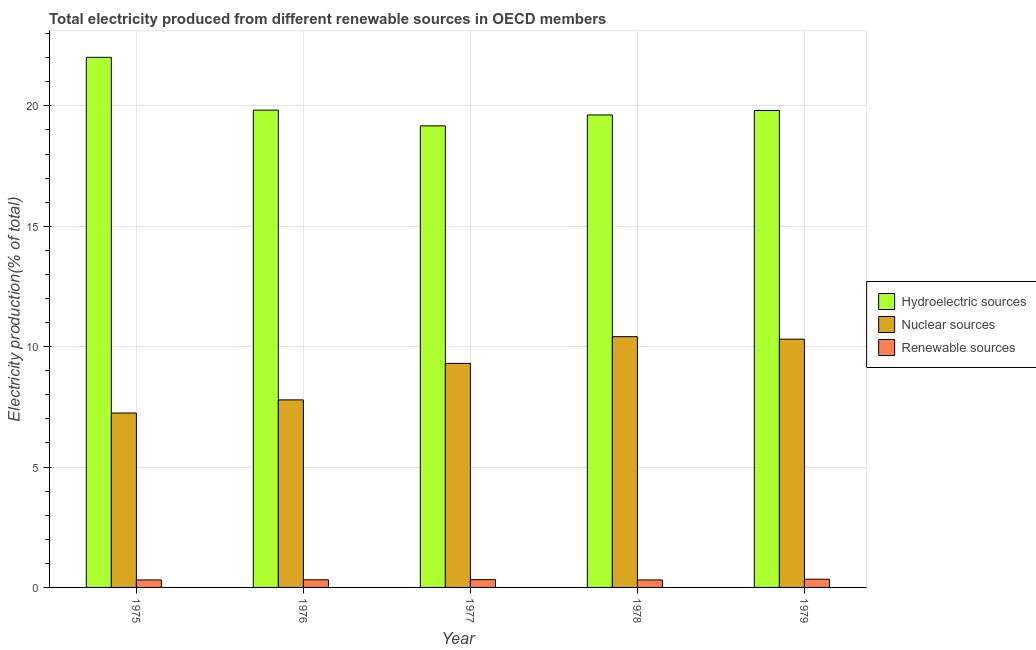Are the number of bars on each tick of the X-axis equal?
Offer a very short reply. Yes. How many bars are there on the 5th tick from the right?
Provide a succinct answer. 3. What is the label of the 4th group of bars from the left?
Give a very brief answer. 1978. In how many cases, is the number of bars for a given year not equal to the number of legend labels?
Provide a short and direct response. 0. What is the percentage of electricity produced by renewable sources in 1977?
Your answer should be very brief. 0.32. Across all years, what is the maximum percentage of electricity produced by renewable sources?
Your response must be concise. 0.34. Across all years, what is the minimum percentage of electricity produced by hydroelectric sources?
Your response must be concise. 19.17. In which year was the percentage of electricity produced by renewable sources maximum?
Ensure brevity in your answer.  1979. In which year was the percentage of electricity produced by renewable sources minimum?
Your answer should be very brief. 1978. What is the total percentage of electricity produced by nuclear sources in the graph?
Your answer should be very brief. 45.06. What is the difference between the percentage of electricity produced by renewable sources in 1976 and that in 1979?
Give a very brief answer. -0.02. What is the difference between the percentage of electricity produced by nuclear sources in 1978 and the percentage of electricity produced by renewable sources in 1977?
Offer a terse response. 1.11. What is the average percentage of electricity produced by hydroelectric sources per year?
Offer a very short reply. 20.09. What is the ratio of the percentage of electricity produced by hydroelectric sources in 1976 to that in 1979?
Make the answer very short. 1. What is the difference between the highest and the second highest percentage of electricity produced by renewable sources?
Your response must be concise. 0.02. What is the difference between the highest and the lowest percentage of electricity produced by hydroelectric sources?
Offer a terse response. 2.85. Is the sum of the percentage of electricity produced by hydroelectric sources in 1975 and 1976 greater than the maximum percentage of electricity produced by nuclear sources across all years?
Ensure brevity in your answer.  Yes. What does the 1st bar from the left in 1979 represents?
Ensure brevity in your answer.  Hydroelectric sources. What does the 1st bar from the right in 1976 represents?
Offer a terse response. Renewable sources. Is it the case that in every year, the sum of the percentage of electricity produced by hydroelectric sources and percentage of electricity produced by nuclear sources is greater than the percentage of electricity produced by renewable sources?
Give a very brief answer. Yes. How many bars are there?
Give a very brief answer. 15. How many years are there in the graph?
Your answer should be very brief. 5. What is the difference between two consecutive major ticks on the Y-axis?
Ensure brevity in your answer.  5. Does the graph contain grids?
Ensure brevity in your answer.  Yes. How are the legend labels stacked?
Provide a succinct answer. Vertical. What is the title of the graph?
Offer a very short reply. Total electricity produced from different renewable sources in OECD members. Does "Private sector" appear as one of the legend labels in the graph?
Your response must be concise. No. What is the label or title of the X-axis?
Your answer should be compact. Year. What is the label or title of the Y-axis?
Provide a succinct answer. Electricity production(% of total). What is the Electricity production(% of total) of Hydroelectric sources in 1975?
Give a very brief answer. 22.02. What is the Electricity production(% of total) of Nuclear sources in 1975?
Your response must be concise. 7.24. What is the Electricity production(% of total) of Renewable sources in 1975?
Offer a very short reply. 0.31. What is the Electricity production(% of total) of Hydroelectric sources in 1976?
Keep it short and to the point. 19.82. What is the Electricity production(% of total) in Nuclear sources in 1976?
Your answer should be very brief. 7.79. What is the Electricity production(% of total) of Renewable sources in 1976?
Your response must be concise. 0.32. What is the Electricity production(% of total) in Hydroelectric sources in 1977?
Ensure brevity in your answer.  19.17. What is the Electricity production(% of total) of Nuclear sources in 1977?
Keep it short and to the point. 9.31. What is the Electricity production(% of total) in Renewable sources in 1977?
Your answer should be compact. 0.32. What is the Electricity production(% of total) in Hydroelectric sources in 1978?
Your response must be concise. 19.62. What is the Electricity production(% of total) in Nuclear sources in 1978?
Provide a succinct answer. 10.42. What is the Electricity production(% of total) of Renewable sources in 1978?
Your answer should be very brief. 0.31. What is the Electricity production(% of total) of Hydroelectric sources in 1979?
Your answer should be very brief. 19.81. What is the Electricity production(% of total) of Nuclear sources in 1979?
Your answer should be very brief. 10.31. What is the Electricity production(% of total) of Renewable sources in 1979?
Provide a succinct answer. 0.34. Across all years, what is the maximum Electricity production(% of total) in Hydroelectric sources?
Give a very brief answer. 22.02. Across all years, what is the maximum Electricity production(% of total) in Nuclear sources?
Give a very brief answer. 10.42. Across all years, what is the maximum Electricity production(% of total) in Renewable sources?
Your answer should be very brief. 0.34. Across all years, what is the minimum Electricity production(% of total) in Hydroelectric sources?
Give a very brief answer. 19.17. Across all years, what is the minimum Electricity production(% of total) in Nuclear sources?
Your response must be concise. 7.24. Across all years, what is the minimum Electricity production(% of total) of Renewable sources?
Keep it short and to the point. 0.31. What is the total Electricity production(% of total) of Hydroelectric sources in the graph?
Keep it short and to the point. 100.44. What is the total Electricity production(% of total) of Nuclear sources in the graph?
Your answer should be compact. 45.06. What is the total Electricity production(% of total) in Renewable sources in the graph?
Provide a succinct answer. 1.6. What is the difference between the Electricity production(% of total) in Hydroelectric sources in 1975 and that in 1976?
Keep it short and to the point. 2.19. What is the difference between the Electricity production(% of total) in Nuclear sources in 1975 and that in 1976?
Make the answer very short. -0.55. What is the difference between the Electricity production(% of total) in Renewable sources in 1975 and that in 1976?
Give a very brief answer. -0.01. What is the difference between the Electricity production(% of total) in Hydroelectric sources in 1975 and that in 1977?
Provide a short and direct response. 2.85. What is the difference between the Electricity production(% of total) in Nuclear sources in 1975 and that in 1977?
Provide a short and direct response. -2.06. What is the difference between the Electricity production(% of total) of Renewable sources in 1975 and that in 1977?
Provide a succinct answer. -0.01. What is the difference between the Electricity production(% of total) in Hydroelectric sources in 1975 and that in 1978?
Give a very brief answer. 2.39. What is the difference between the Electricity production(% of total) of Nuclear sources in 1975 and that in 1978?
Keep it short and to the point. -3.17. What is the difference between the Electricity production(% of total) in Hydroelectric sources in 1975 and that in 1979?
Offer a terse response. 2.21. What is the difference between the Electricity production(% of total) in Nuclear sources in 1975 and that in 1979?
Your answer should be compact. -3.07. What is the difference between the Electricity production(% of total) of Renewable sources in 1975 and that in 1979?
Provide a succinct answer. -0.03. What is the difference between the Electricity production(% of total) in Hydroelectric sources in 1976 and that in 1977?
Provide a succinct answer. 0.65. What is the difference between the Electricity production(% of total) of Nuclear sources in 1976 and that in 1977?
Keep it short and to the point. -1.52. What is the difference between the Electricity production(% of total) in Renewable sources in 1976 and that in 1977?
Your response must be concise. -0.01. What is the difference between the Electricity production(% of total) of Hydroelectric sources in 1976 and that in 1978?
Your response must be concise. 0.2. What is the difference between the Electricity production(% of total) of Nuclear sources in 1976 and that in 1978?
Your answer should be very brief. -2.63. What is the difference between the Electricity production(% of total) in Renewable sources in 1976 and that in 1978?
Make the answer very short. 0.01. What is the difference between the Electricity production(% of total) of Hydroelectric sources in 1976 and that in 1979?
Ensure brevity in your answer.  0.02. What is the difference between the Electricity production(% of total) in Nuclear sources in 1976 and that in 1979?
Provide a succinct answer. -2.52. What is the difference between the Electricity production(% of total) in Renewable sources in 1976 and that in 1979?
Your answer should be very brief. -0.02. What is the difference between the Electricity production(% of total) of Hydroelectric sources in 1977 and that in 1978?
Ensure brevity in your answer.  -0.45. What is the difference between the Electricity production(% of total) in Nuclear sources in 1977 and that in 1978?
Make the answer very short. -1.11. What is the difference between the Electricity production(% of total) in Renewable sources in 1977 and that in 1978?
Provide a short and direct response. 0.01. What is the difference between the Electricity production(% of total) of Hydroelectric sources in 1977 and that in 1979?
Make the answer very short. -0.64. What is the difference between the Electricity production(% of total) in Nuclear sources in 1977 and that in 1979?
Your response must be concise. -1.01. What is the difference between the Electricity production(% of total) of Renewable sources in 1977 and that in 1979?
Offer a terse response. -0.02. What is the difference between the Electricity production(% of total) of Hydroelectric sources in 1978 and that in 1979?
Ensure brevity in your answer.  -0.18. What is the difference between the Electricity production(% of total) in Nuclear sources in 1978 and that in 1979?
Your answer should be compact. 0.1. What is the difference between the Electricity production(% of total) of Renewable sources in 1978 and that in 1979?
Give a very brief answer. -0.03. What is the difference between the Electricity production(% of total) of Hydroelectric sources in 1975 and the Electricity production(% of total) of Nuclear sources in 1976?
Provide a succinct answer. 14.23. What is the difference between the Electricity production(% of total) of Hydroelectric sources in 1975 and the Electricity production(% of total) of Renewable sources in 1976?
Your answer should be compact. 21.7. What is the difference between the Electricity production(% of total) of Nuclear sources in 1975 and the Electricity production(% of total) of Renewable sources in 1976?
Your answer should be very brief. 6.93. What is the difference between the Electricity production(% of total) of Hydroelectric sources in 1975 and the Electricity production(% of total) of Nuclear sources in 1977?
Your answer should be compact. 12.71. What is the difference between the Electricity production(% of total) of Hydroelectric sources in 1975 and the Electricity production(% of total) of Renewable sources in 1977?
Your answer should be very brief. 21.69. What is the difference between the Electricity production(% of total) of Nuclear sources in 1975 and the Electricity production(% of total) of Renewable sources in 1977?
Ensure brevity in your answer.  6.92. What is the difference between the Electricity production(% of total) of Hydroelectric sources in 1975 and the Electricity production(% of total) of Nuclear sources in 1978?
Ensure brevity in your answer.  11.6. What is the difference between the Electricity production(% of total) in Hydroelectric sources in 1975 and the Electricity production(% of total) in Renewable sources in 1978?
Provide a succinct answer. 21.71. What is the difference between the Electricity production(% of total) in Nuclear sources in 1975 and the Electricity production(% of total) in Renewable sources in 1978?
Keep it short and to the point. 6.93. What is the difference between the Electricity production(% of total) in Hydroelectric sources in 1975 and the Electricity production(% of total) in Nuclear sources in 1979?
Provide a succinct answer. 11.71. What is the difference between the Electricity production(% of total) in Hydroelectric sources in 1975 and the Electricity production(% of total) in Renewable sources in 1979?
Your answer should be very brief. 21.68. What is the difference between the Electricity production(% of total) in Nuclear sources in 1975 and the Electricity production(% of total) in Renewable sources in 1979?
Give a very brief answer. 6.9. What is the difference between the Electricity production(% of total) in Hydroelectric sources in 1976 and the Electricity production(% of total) in Nuclear sources in 1977?
Your answer should be compact. 10.52. What is the difference between the Electricity production(% of total) in Hydroelectric sources in 1976 and the Electricity production(% of total) in Renewable sources in 1977?
Offer a terse response. 19.5. What is the difference between the Electricity production(% of total) in Nuclear sources in 1976 and the Electricity production(% of total) in Renewable sources in 1977?
Your answer should be compact. 7.47. What is the difference between the Electricity production(% of total) of Hydroelectric sources in 1976 and the Electricity production(% of total) of Nuclear sources in 1978?
Provide a succinct answer. 9.41. What is the difference between the Electricity production(% of total) of Hydroelectric sources in 1976 and the Electricity production(% of total) of Renewable sources in 1978?
Make the answer very short. 19.51. What is the difference between the Electricity production(% of total) in Nuclear sources in 1976 and the Electricity production(% of total) in Renewable sources in 1978?
Keep it short and to the point. 7.48. What is the difference between the Electricity production(% of total) in Hydroelectric sources in 1976 and the Electricity production(% of total) in Nuclear sources in 1979?
Provide a short and direct response. 9.51. What is the difference between the Electricity production(% of total) of Hydroelectric sources in 1976 and the Electricity production(% of total) of Renewable sources in 1979?
Provide a short and direct response. 19.48. What is the difference between the Electricity production(% of total) in Nuclear sources in 1976 and the Electricity production(% of total) in Renewable sources in 1979?
Make the answer very short. 7.45. What is the difference between the Electricity production(% of total) of Hydroelectric sources in 1977 and the Electricity production(% of total) of Nuclear sources in 1978?
Provide a short and direct response. 8.75. What is the difference between the Electricity production(% of total) of Hydroelectric sources in 1977 and the Electricity production(% of total) of Renewable sources in 1978?
Offer a terse response. 18.86. What is the difference between the Electricity production(% of total) of Nuclear sources in 1977 and the Electricity production(% of total) of Renewable sources in 1978?
Your answer should be compact. 8.99. What is the difference between the Electricity production(% of total) in Hydroelectric sources in 1977 and the Electricity production(% of total) in Nuclear sources in 1979?
Ensure brevity in your answer.  8.86. What is the difference between the Electricity production(% of total) in Hydroelectric sources in 1977 and the Electricity production(% of total) in Renewable sources in 1979?
Make the answer very short. 18.83. What is the difference between the Electricity production(% of total) in Nuclear sources in 1977 and the Electricity production(% of total) in Renewable sources in 1979?
Provide a short and direct response. 8.96. What is the difference between the Electricity production(% of total) of Hydroelectric sources in 1978 and the Electricity production(% of total) of Nuclear sources in 1979?
Your answer should be very brief. 9.31. What is the difference between the Electricity production(% of total) in Hydroelectric sources in 1978 and the Electricity production(% of total) in Renewable sources in 1979?
Your answer should be very brief. 19.28. What is the difference between the Electricity production(% of total) of Nuclear sources in 1978 and the Electricity production(% of total) of Renewable sources in 1979?
Your answer should be compact. 10.07. What is the average Electricity production(% of total) of Hydroelectric sources per year?
Your answer should be compact. 20.09. What is the average Electricity production(% of total) of Nuclear sources per year?
Provide a short and direct response. 9.01. What is the average Electricity production(% of total) of Renewable sources per year?
Make the answer very short. 0.32. In the year 1975, what is the difference between the Electricity production(% of total) in Hydroelectric sources and Electricity production(% of total) in Nuclear sources?
Offer a very short reply. 14.77. In the year 1975, what is the difference between the Electricity production(% of total) of Hydroelectric sources and Electricity production(% of total) of Renewable sources?
Your response must be concise. 21.7. In the year 1975, what is the difference between the Electricity production(% of total) of Nuclear sources and Electricity production(% of total) of Renewable sources?
Your answer should be compact. 6.93. In the year 1976, what is the difference between the Electricity production(% of total) of Hydroelectric sources and Electricity production(% of total) of Nuclear sources?
Provide a short and direct response. 12.03. In the year 1976, what is the difference between the Electricity production(% of total) of Hydroelectric sources and Electricity production(% of total) of Renewable sources?
Provide a succinct answer. 19.51. In the year 1976, what is the difference between the Electricity production(% of total) of Nuclear sources and Electricity production(% of total) of Renewable sources?
Provide a succinct answer. 7.47. In the year 1977, what is the difference between the Electricity production(% of total) of Hydroelectric sources and Electricity production(% of total) of Nuclear sources?
Ensure brevity in your answer.  9.86. In the year 1977, what is the difference between the Electricity production(% of total) in Hydroelectric sources and Electricity production(% of total) in Renewable sources?
Keep it short and to the point. 18.85. In the year 1977, what is the difference between the Electricity production(% of total) in Nuclear sources and Electricity production(% of total) in Renewable sources?
Make the answer very short. 8.98. In the year 1978, what is the difference between the Electricity production(% of total) of Hydroelectric sources and Electricity production(% of total) of Nuclear sources?
Offer a terse response. 9.21. In the year 1978, what is the difference between the Electricity production(% of total) of Hydroelectric sources and Electricity production(% of total) of Renewable sources?
Offer a very short reply. 19.31. In the year 1978, what is the difference between the Electricity production(% of total) of Nuclear sources and Electricity production(% of total) of Renewable sources?
Your response must be concise. 10.1. In the year 1979, what is the difference between the Electricity production(% of total) of Hydroelectric sources and Electricity production(% of total) of Nuclear sources?
Make the answer very short. 9.5. In the year 1979, what is the difference between the Electricity production(% of total) of Hydroelectric sources and Electricity production(% of total) of Renewable sources?
Ensure brevity in your answer.  19.47. In the year 1979, what is the difference between the Electricity production(% of total) of Nuclear sources and Electricity production(% of total) of Renewable sources?
Provide a succinct answer. 9.97. What is the ratio of the Electricity production(% of total) of Hydroelectric sources in 1975 to that in 1976?
Your answer should be compact. 1.11. What is the ratio of the Electricity production(% of total) of Nuclear sources in 1975 to that in 1976?
Ensure brevity in your answer.  0.93. What is the ratio of the Electricity production(% of total) in Renewable sources in 1975 to that in 1976?
Ensure brevity in your answer.  0.98. What is the ratio of the Electricity production(% of total) of Hydroelectric sources in 1975 to that in 1977?
Keep it short and to the point. 1.15. What is the ratio of the Electricity production(% of total) in Nuclear sources in 1975 to that in 1977?
Provide a short and direct response. 0.78. What is the ratio of the Electricity production(% of total) of Hydroelectric sources in 1975 to that in 1978?
Ensure brevity in your answer.  1.12. What is the ratio of the Electricity production(% of total) in Nuclear sources in 1975 to that in 1978?
Keep it short and to the point. 0.7. What is the ratio of the Electricity production(% of total) of Hydroelectric sources in 1975 to that in 1979?
Offer a terse response. 1.11. What is the ratio of the Electricity production(% of total) of Nuclear sources in 1975 to that in 1979?
Provide a succinct answer. 0.7. What is the ratio of the Electricity production(% of total) of Hydroelectric sources in 1976 to that in 1977?
Your response must be concise. 1.03. What is the ratio of the Electricity production(% of total) in Nuclear sources in 1976 to that in 1977?
Provide a succinct answer. 0.84. What is the ratio of the Electricity production(% of total) of Renewable sources in 1976 to that in 1977?
Provide a succinct answer. 0.98. What is the ratio of the Electricity production(% of total) in Hydroelectric sources in 1976 to that in 1978?
Make the answer very short. 1.01. What is the ratio of the Electricity production(% of total) of Nuclear sources in 1976 to that in 1978?
Keep it short and to the point. 0.75. What is the ratio of the Electricity production(% of total) of Renewable sources in 1976 to that in 1978?
Keep it short and to the point. 1.02. What is the ratio of the Electricity production(% of total) in Hydroelectric sources in 1976 to that in 1979?
Offer a very short reply. 1. What is the ratio of the Electricity production(% of total) in Nuclear sources in 1976 to that in 1979?
Give a very brief answer. 0.76. What is the ratio of the Electricity production(% of total) in Renewable sources in 1976 to that in 1979?
Offer a terse response. 0.93. What is the ratio of the Electricity production(% of total) of Hydroelectric sources in 1977 to that in 1978?
Ensure brevity in your answer.  0.98. What is the ratio of the Electricity production(% of total) in Nuclear sources in 1977 to that in 1978?
Ensure brevity in your answer.  0.89. What is the ratio of the Electricity production(% of total) of Renewable sources in 1977 to that in 1978?
Your answer should be very brief. 1.04. What is the ratio of the Electricity production(% of total) in Hydroelectric sources in 1977 to that in 1979?
Provide a short and direct response. 0.97. What is the ratio of the Electricity production(% of total) in Nuclear sources in 1977 to that in 1979?
Provide a succinct answer. 0.9. What is the ratio of the Electricity production(% of total) in Renewable sources in 1977 to that in 1979?
Give a very brief answer. 0.95. What is the ratio of the Electricity production(% of total) of Hydroelectric sources in 1978 to that in 1979?
Offer a very short reply. 0.99. What is the ratio of the Electricity production(% of total) in Nuclear sources in 1978 to that in 1979?
Keep it short and to the point. 1.01. What is the ratio of the Electricity production(% of total) of Renewable sources in 1978 to that in 1979?
Your answer should be very brief. 0.91. What is the difference between the highest and the second highest Electricity production(% of total) in Hydroelectric sources?
Offer a terse response. 2.19. What is the difference between the highest and the second highest Electricity production(% of total) of Nuclear sources?
Give a very brief answer. 0.1. What is the difference between the highest and the second highest Electricity production(% of total) in Renewable sources?
Your response must be concise. 0.02. What is the difference between the highest and the lowest Electricity production(% of total) of Hydroelectric sources?
Keep it short and to the point. 2.85. What is the difference between the highest and the lowest Electricity production(% of total) of Nuclear sources?
Offer a very short reply. 3.17. What is the difference between the highest and the lowest Electricity production(% of total) of Renewable sources?
Offer a terse response. 0.03. 